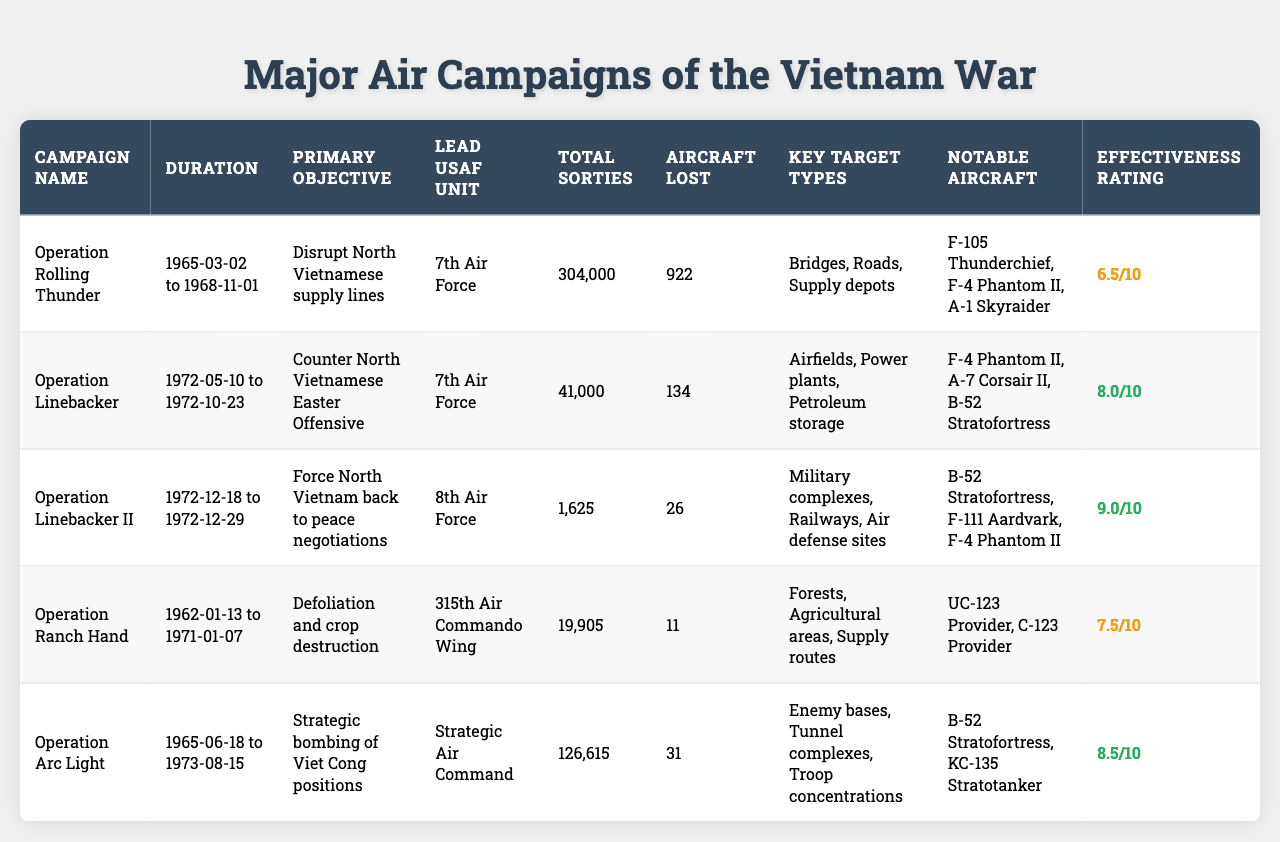What is the duration of Operation Linebacker II? Operation Linebacker II started on December 18, 1972, and ended on December 29, 1972. The duration can be calculated by determining the period from the start date to the end date, which is 12 days.
Answer: 12 days Which air campaign had the highest effectiveness rating? By comparing the effectiveness ratings of all air campaigns in the table, Operation Linebacker II has the highest rating at 9.0.
Answer: Operation Linebacker II How many total sorties were flown during Operation Rolling Thunder? The table lists that a total of 304,000 sorties were flown during Operation Rolling Thunder, as indicated in the "Total Sorties" column.
Answer: 304,000 sorties What are the key target types for Operation Linebacker? The key target types for Operation Linebacker include airfields, power plants, and petroleum storage, as listed in the table under "Key Target Types."
Answer: Airfields, power plants, petroleum storage What is the difference in the number of aircraft lost between Operation Arc Light and Operation Ranch Hand? Operation Arc Light lost 31 aircraft, and Operation Ranch Hand lost 11 aircraft. The difference is calculated as 31 - 11 = 20.
Answer: 20 aircraft Which air campaign involved defoliation and crop destruction? The campaign with the objective of defoliation and crop destruction is Operation Ranch Hand, which is clearly stated in the "Primary Objective" column.
Answer: Operation Ranch Hand Is the total number of sorties for Operation Linebacker greater than that for Operation Rolling Thunder? Operation Linebacker had 41,000 sorties, while Operation Rolling Thunder had 304,000 sorties. Since 41,000 < 304,000, the statement is false.
Answer: No Which air campaign had the highest number of aircraft lost? Comparing the aircraft lost in each campaign, Operation Rolling Thunder had the highest loss with 922 aircraft.
Answer: Operation Rolling Thunder What was the effectiveness rating for Operation Ranch Hand? The effectiveness rating for Operation Ranch Hand is 7.5, as specified in the table.
Answer: 7.5 After comparing the total sorties, which air campaign had the least amount? Operation Linebacker II had the least amount of sorties with a total of 1,625, as shown in the "Total Sorties" column.
Answer: Operation Linebacker II 